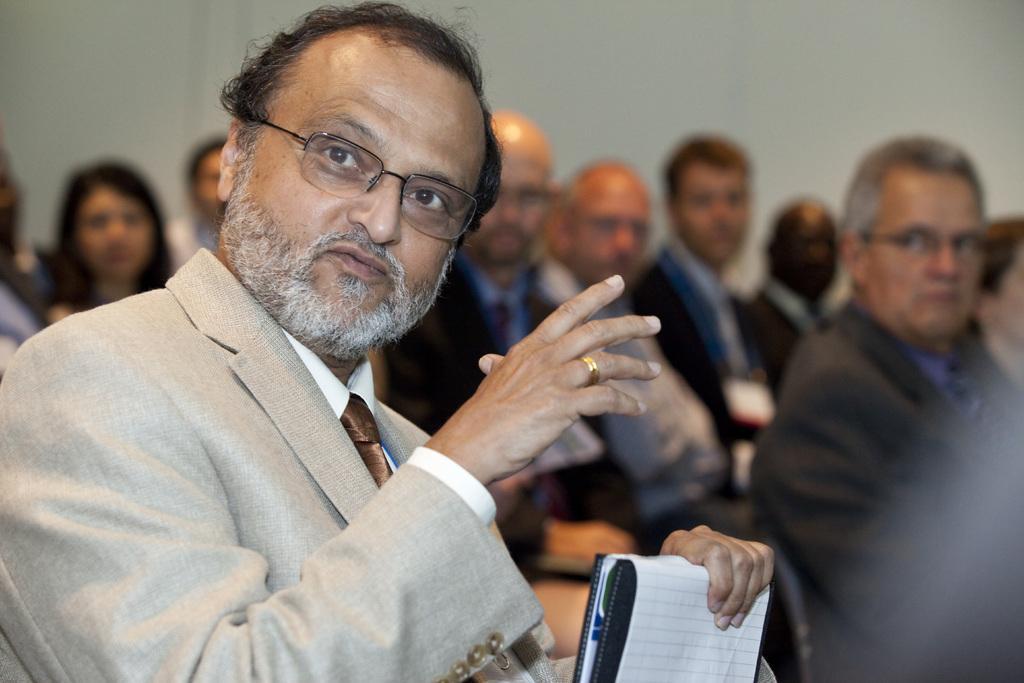Can you describe this image briefly? This picture describes about group of people, on the left side of the image we can see a man, he wore spectacles and he is holding a book. 